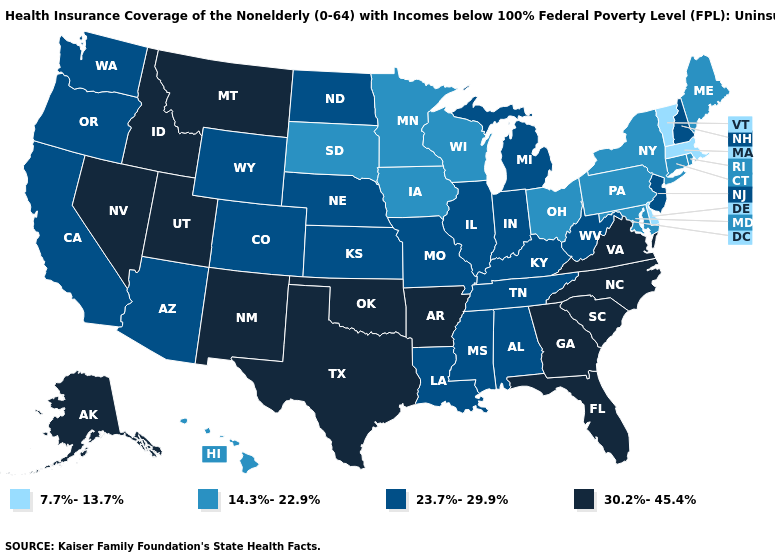Which states have the lowest value in the West?
Keep it brief. Hawaii. What is the lowest value in the South?
Write a very short answer. 7.7%-13.7%. What is the lowest value in the South?
Answer briefly. 7.7%-13.7%. Does Georgia have the highest value in the USA?
Write a very short answer. Yes. Does the map have missing data?
Quick response, please. No. Does Wisconsin have the highest value in the MidWest?
Short answer required. No. Name the states that have a value in the range 14.3%-22.9%?
Give a very brief answer. Connecticut, Hawaii, Iowa, Maine, Maryland, Minnesota, New York, Ohio, Pennsylvania, Rhode Island, South Dakota, Wisconsin. What is the lowest value in states that border South Carolina?
Answer briefly. 30.2%-45.4%. What is the lowest value in the USA?
Short answer required. 7.7%-13.7%. Does the map have missing data?
Quick response, please. No. Name the states that have a value in the range 14.3%-22.9%?
Short answer required. Connecticut, Hawaii, Iowa, Maine, Maryland, Minnesota, New York, Ohio, Pennsylvania, Rhode Island, South Dakota, Wisconsin. What is the value of North Carolina?
Concise answer only. 30.2%-45.4%. What is the highest value in the USA?
Answer briefly. 30.2%-45.4%. Which states hav the highest value in the MidWest?
Write a very short answer. Illinois, Indiana, Kansas, Michigan, Missouri, Nebraska, North Dakota. 